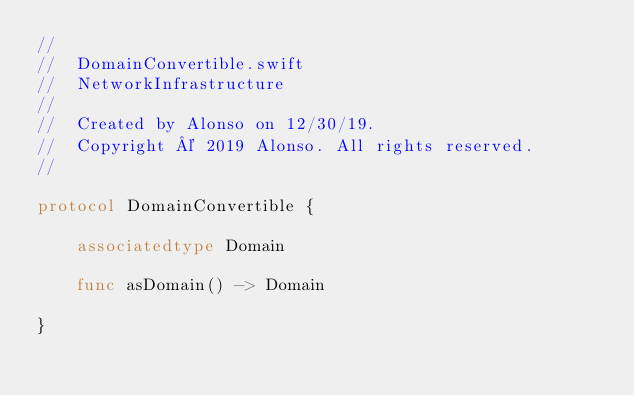<code> <loc_0><loc_0><loc_500><loc_500><_Swift_>//
//  DomainConvertible.swift
//  NetworkInfrastructure
//
//  Created by Alonso on 12/30/19.
//  Copyright © 2019 Alonso. All rights reserved.
//

protocol DomainConvertible {

    associatedtype Domain

    func asDomain() -> Domain

}
</code> 